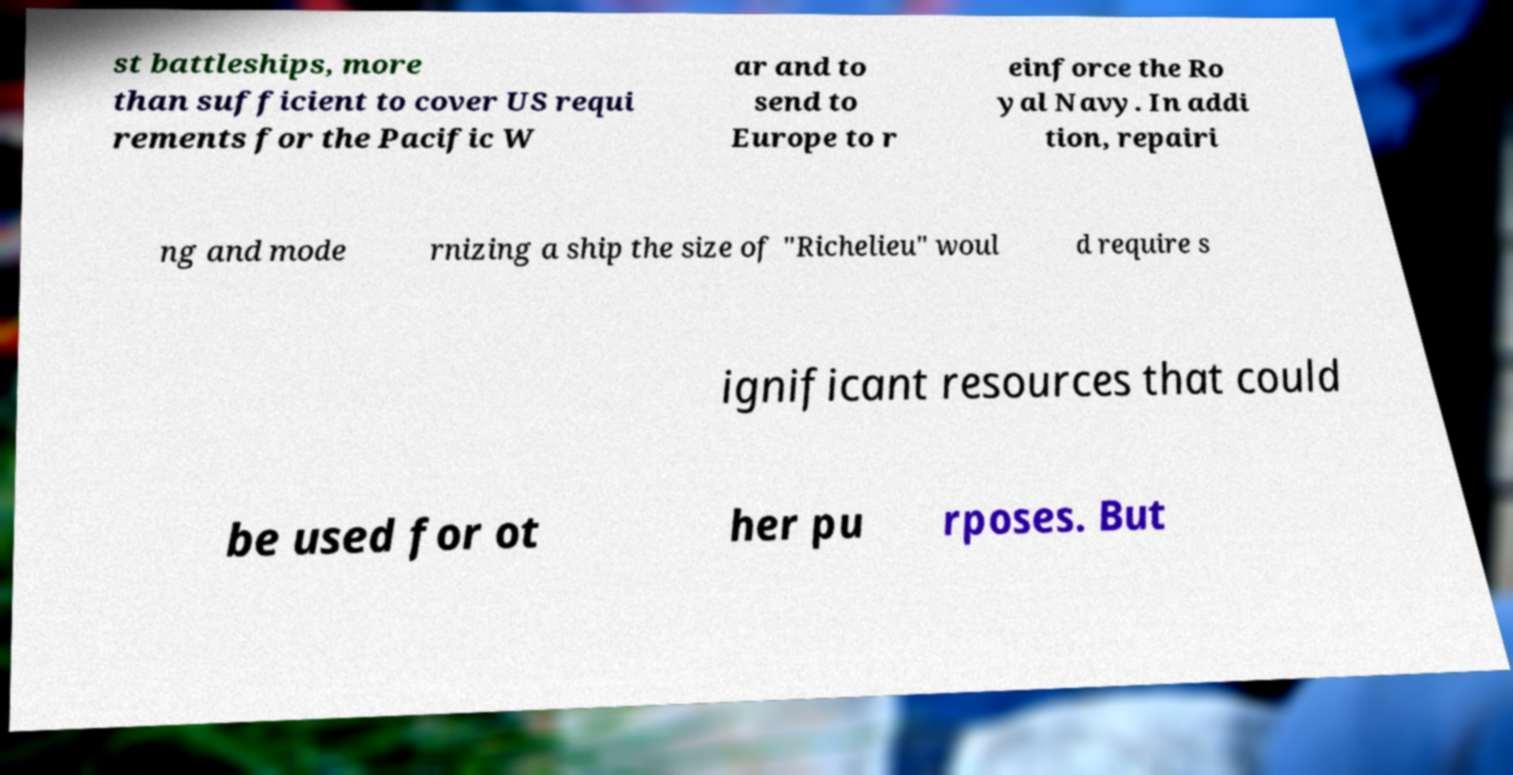There's text embedded in this image that I need extracted. Can you transcribe it verbatim? st battleships, more than sufficient to cover US requi rements for the Pacific W ar and to send to Europe to r einforce the Ro yal Navy. In addi tion, repairi ng and mode rnizing a ship the size of "Richelieu" woul d require s ignificant resources that could be used for ot her pu rposes. But 